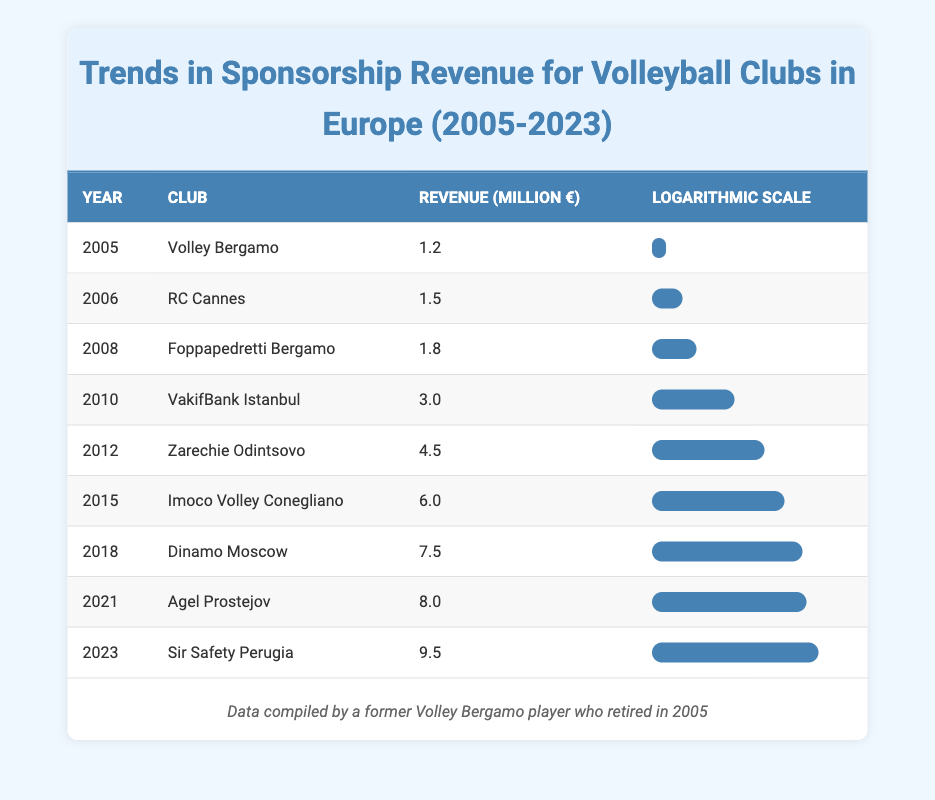What was the sponsorship revenue for Volley Bergamo in 2005? In the table, under the year 2005 and for the club Volley Bergamo, the revenue is specified as 1.2 million euros.
Answer: 1.2 million euros Which club had the highest sponsorship revenue in 2023? Looking at the year 2023 in the table, the club Sir Safety Perugia has the highest sponsorship revenue listed, which is 9.5 million euros.
Answer: Sir Safety Perugia What is the revenue difference between Dinamo Moscow in 2018 and Agel Prostejov in 2021? In 2018, Dinamo Moscow had a revenue of 7.5 million euros, and in 2021, Agel Prostejov had a revenue of 8.0 million euros. To find the difference, we subtract 7.5 from 8.0, which gives us 0.5 million euros.
Answer: 0.5 million euros Did any club's sponsorship revenue decline between 2005 and 2023? A review of the table shows that all clubs listed have increasing revenues each year from 2005 to 2023, meaning there were no declines. Therefore, the answer is no.
Answer: No What is the average sponsorship revenue from 2005 to 2023? To find the average, we first sum all revenues: 1.2 + 1.5 + 1.8 + 3.0 + 4.5 + 6.0 + 7.5 + 8.0 + 9.5 = 43.0 million euros. There are 9 data points (years). Now we calculate the average: 43.0 / 9 = 4.78 million euros approximately.
Answer: 4.78 million euros Identify the club with the highest increase in sponsorship revenue between consecutive years. By looking at the revenues for consecutive years: 
- From 2015 (6.0 million euros) to 2018 (7.5 million euros), the increase is 1.5 million euros.
- From 2021 (8.0 million euros) to 2023 (9.5 million euros), the increase is 1.5 million euros.
Analyzing all rows, the highest increase is found to be 1.5 million euros for two pairs: Imoco Volley Conegliano to Dinamo Moscow and Agel Prostejov to Sir Safety Perugia.
Answer: 1.5 million euros What was the revenue trend for Zarechie Odintsovo from 2010 to 2012? In 2010, Zarechie Odintsovo does not have a value (it appears in 2012 with 4.5 million euros). The trend cannot be established from available data since it is not listed for 2010.
Answer: No trend established Which year saw an increase larger than 2 million euros from the previous year? By tracking the revenue changes year by year, the increase from 2012 (4.5 million euros) to 2015 (6.0 million euros) is 1.5 million euros, and from 2015 to 2018 is 1.5 million euros. All increases are less than 2 million euros. Thus, there were no years with a larger increase.
Answer: No years What was the total sponsorship revenue for all clubs in 2018 and 2021 combined? The total for 2018 (7.5 million euros) and 2021 (8.0 million euros) is simply added together: 7.5 + 8.0 = 15.5 million euros.
Answer: 15.5 million euros 